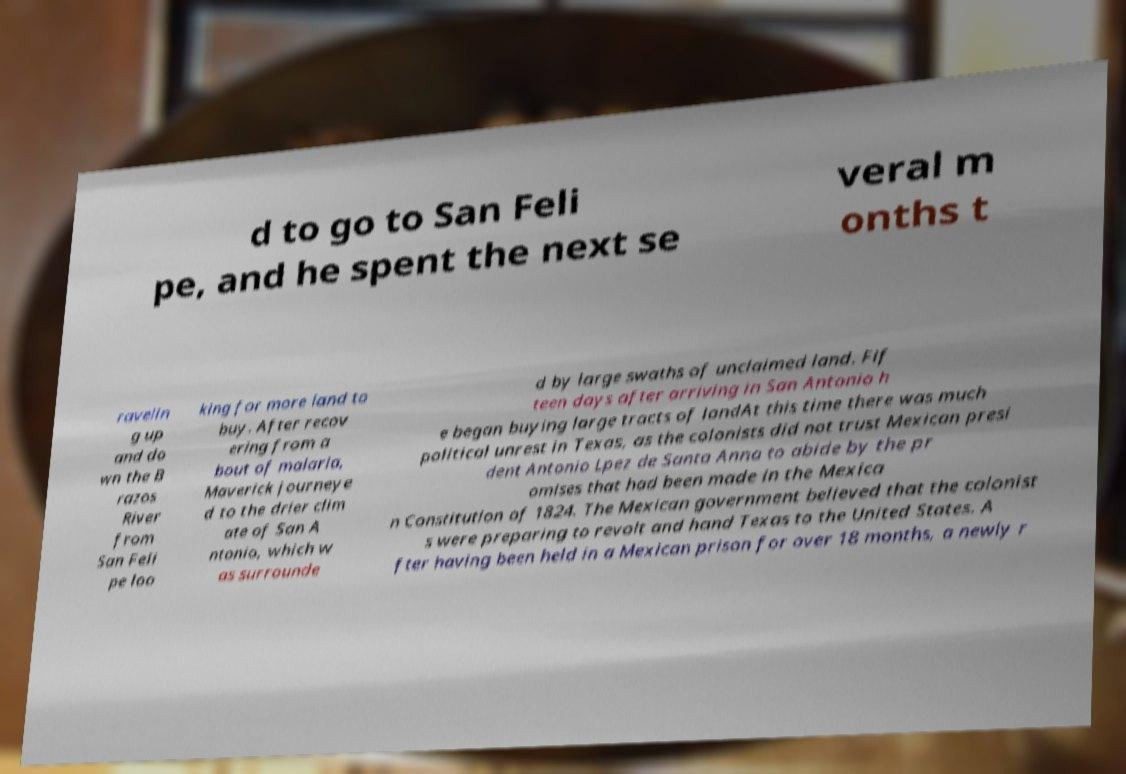There's text embedded in this image that I need extracted. Can you transcribe it verbatim? d to go to San Feli pe, and he spent the next se veral m onths t ravelin g up and do wn the B razos River from San Feli pe loo king for more land to buy. After recov ering from a bout of malaria, Maverick journeye d to the drier clim ate of San A ntonio, which w as surrounde d by large swaths of unclaimed land. Fif teen days after arriving in San Antonio h e began buying large tracts of landAt this time there was much political unrest in Texas, as the colonists did not trust Mexican presi dent Antonio Lpez de Santa Anna to abide by the pr omises that had been made in the Mexica n Constitution of 1824. The Mexican government believed that the colonist s were preparing to revolt and hand Texas to the United States. A fter having been held in a Mexican prison for over 18 months, a newly r 